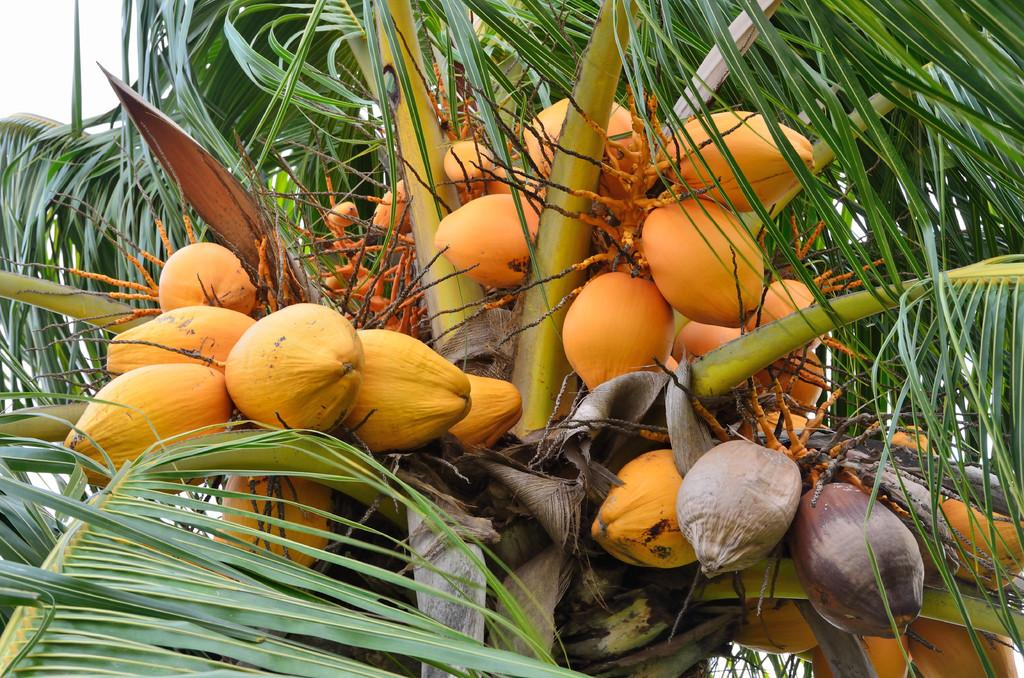What type of plant is present in the image? There is a tree with fruits in the image. What can be seen in the background of the image? The sky is visible in the left top of the image. What type of tent is set up near the tree in the image? There is no tent present in the image; it only features a tree with fruits and the sky visible in the left top. 